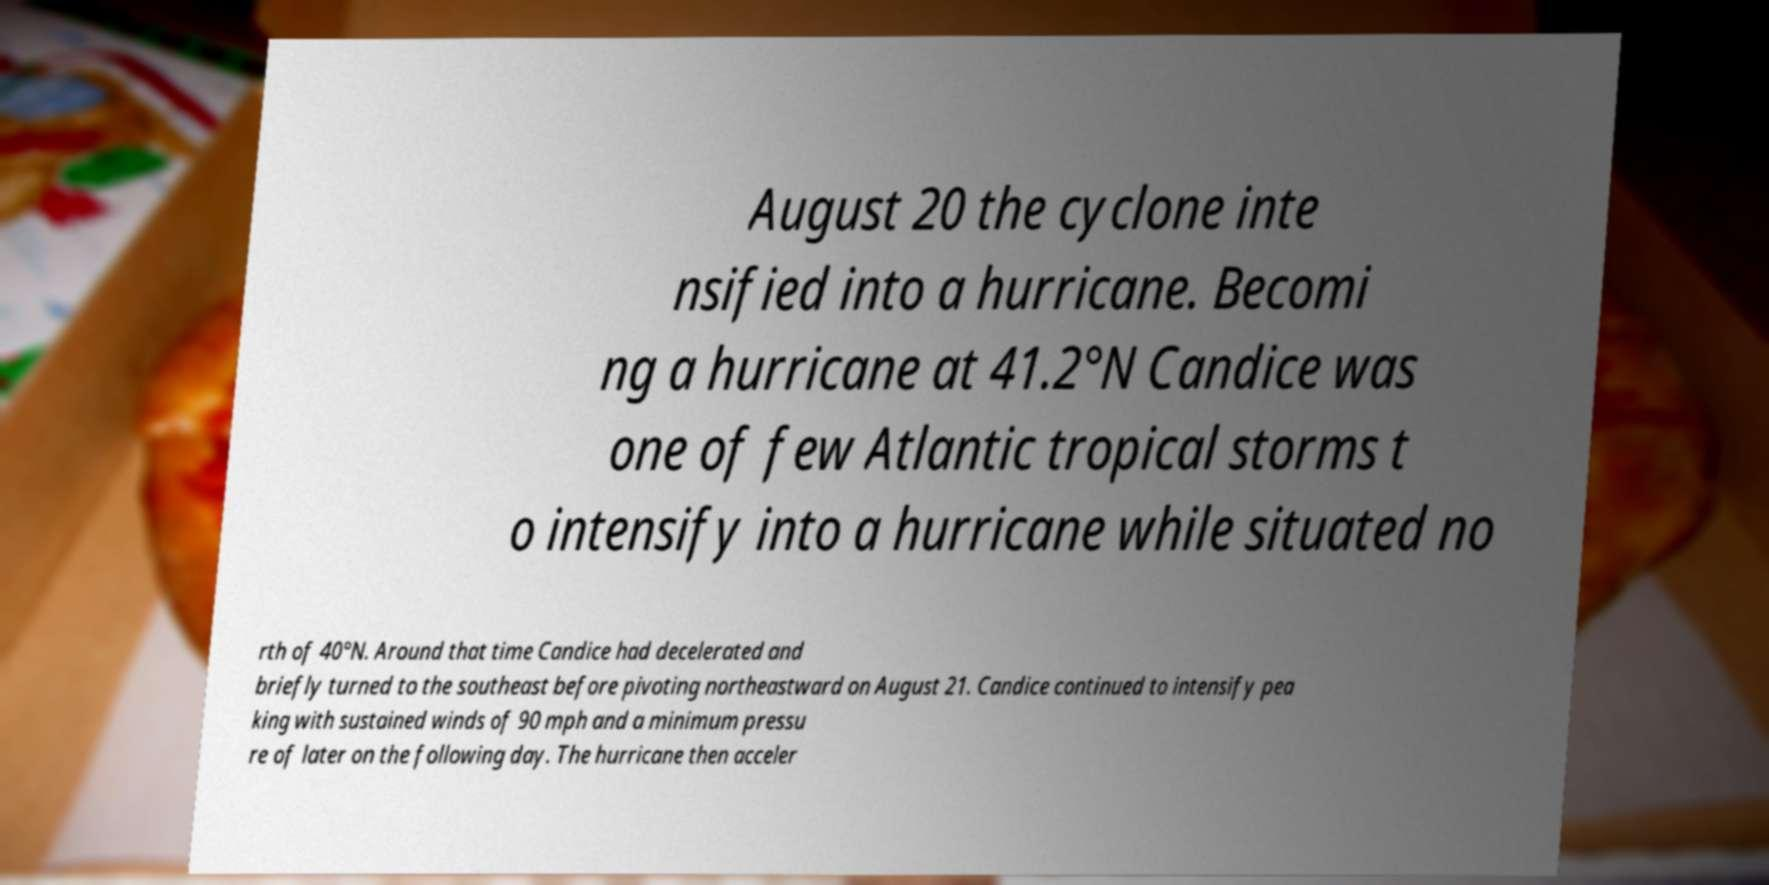There's text embedded in this image that I need extracted. Can you transcribe it verbatim? August 20 the cyclone inte nsified into a hurricane. Becomi ng a hurricane at 41.2°N Candice was one of few Atlantic tropical storms t o intensify into a hurricane while situated no rth of 40°N. Around that time Candice had decelerated and briefly turned to the southeast before pivoting northeastward on August 21. Candice continued to intensify pea king with sustained winds of 90 mph and a minimum pressu re of later on the following day. The hurricane then acceler 